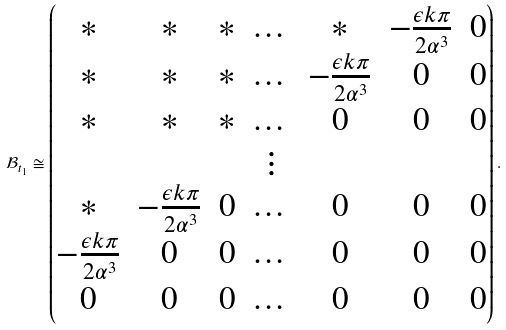<formula> <loc_0><loc_0><loc_500><loc_500>\mathcal { B } _ { t _ { 1 } } \cong \begin{pmatrix} * & * & * & \dots & * & - \frac { \epsilon k \pi } { 2 \alpha ^ { 3 } } & 0 \\ * & * & * & \dots & - \frac { \epsilon k \pi } { 2 \alpha ^ { 3 } } & 0 & 0 \\ * & * & * & \dots & 0 & 0 & 0 \\ & & & \vdots \\ * & - \frac { \epsilon k \pi } { 2 \alpha ^ { 3 } } & 0 & \dots & 0 & 0 & 0 \\ - \frac { \epsilon k \pi } { 2 \alpha ^ { 3 } } & 0 & 0 & \dots & 0 & 0 & 0 \\ 0 & 0 & 0 & \dots & 0 & 0 & 0 \end{pmatrix} .</formula> 